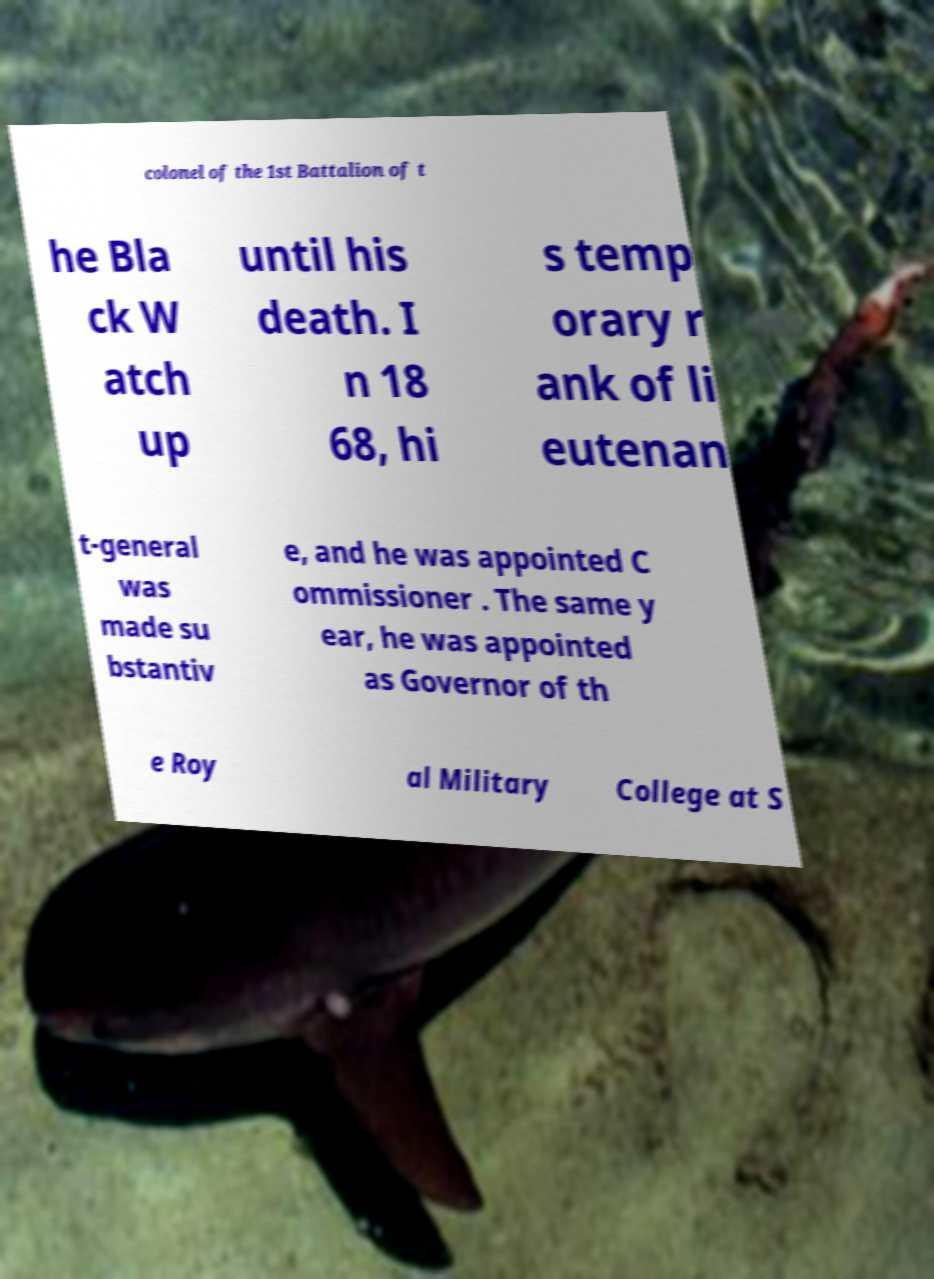What messages or text are displayed in this image? I need them in a readable, typed format. colonel of the 1st Battalion of t he Bla ck W atch up until his death. I n 18 68, hi s temp orary r ank of li eutenan t-general was made su bstantiv e, and he was appointed C ommissioner . The same y ear, he was appointed as Governor of th e Roy al Military College at S 